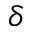<formula> <loc_0><loc_0><loc_500><loc_500>\delta</formula> 